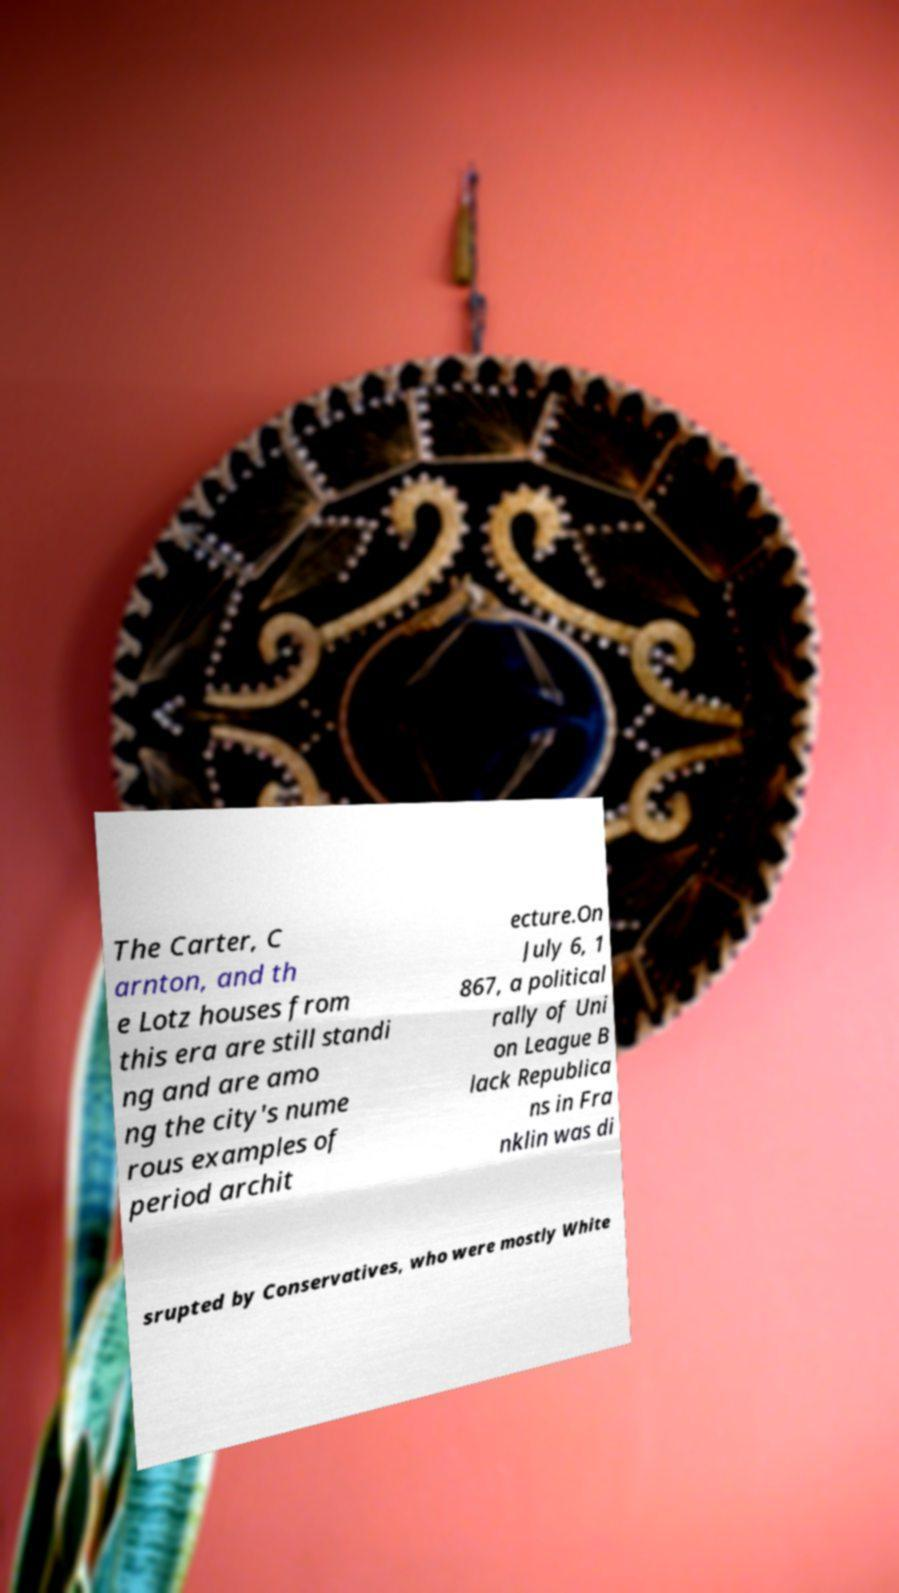For documentation purposes, I need the text within this image transcribed. Could you provide that? The Carter, C arnton, and th e Lotz houses from this era are still standi ng and are amo ng the city's nume rous examples of period archit ecture.On July 6, 1 867, a political rally of Uni on League B lack Republica ns in Fra nklin was di srupted by Conservatives, who were mostly White 